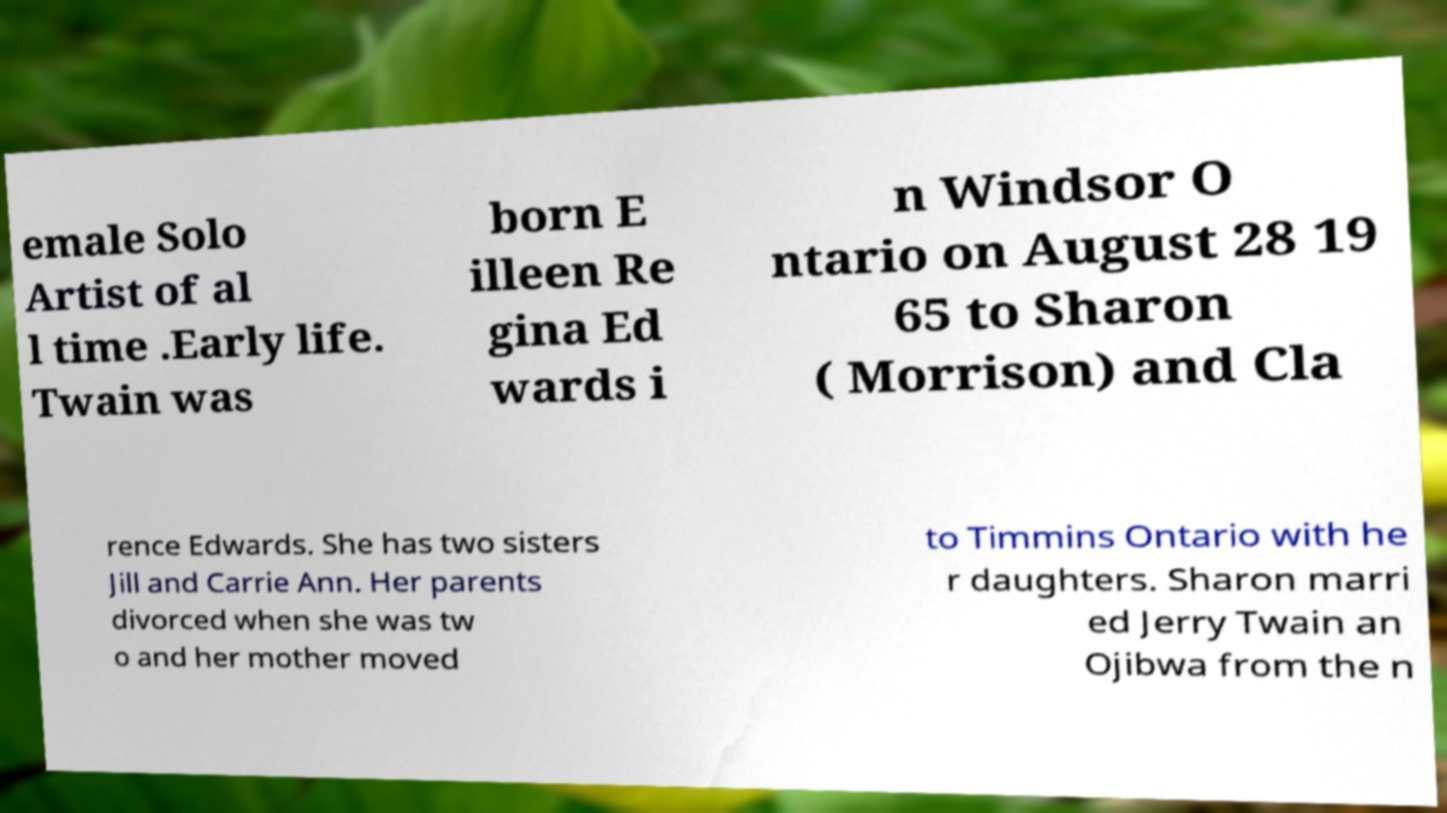Could you assist in decoding the text presented in this image and type it out clearly? emale Solo Artist of al l time .Early life. Twain was born E illeen Re gina Ed wards i n Windsor O ntario on August 28 19 65 to Sharon ( Morrison) and Cla rence Edwards. She has two sisters Jill and Carrie Ann. Her parents divorced when she was tw o and her mother moved to Timmins Ontario with he r daughters. Sharon marri ed Jerry Twain an Ojibwa from the n 